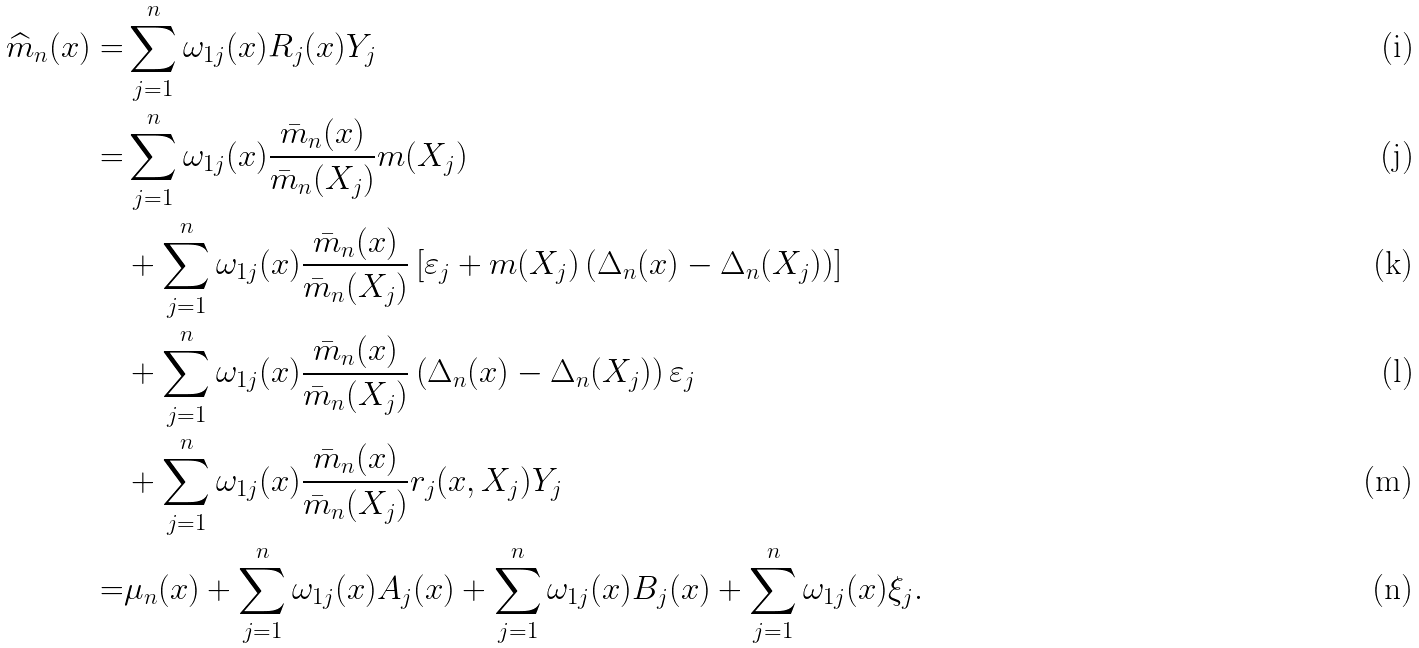Convert formula to latex. <formula><loc_0><loc_0><loc_500><loc_500>\widehat { m } _ { n } ( x ) = & \sum _ { j = 1 } ^ { n } \omega _ { 1 j } ( x ) R _ { j } ( x ) Y _ { j } \\ = & \sum _ { j = 1 } ^ { n } \omega _ { 1 j } ( x ) \frac { \bar { m } _ { n } ( x ) } { \bar { m } _ { n } ( X _ { j } ) } m ( X _ { j } ) \\ \quad & + \sum _ { j = 1 } ^ { n } \omega _ { 1 j } ( x ) \frac { \bar { m } _ { n } ( x ) } { \bar { m } _ { n } ( X _ { j } ) } \left [ \varepsilon _ { j } + m ( X _ { j } ) \left ( \Delta _ { n } ( x ) - \Delta _ { n } ( X _ { j } ) \right ) \right ] \\ \quad & + \sum _ { j = 1 } ^ { n } \omega _ { 1 j } ( x ) \frac { \bar { m } _ { n } ( x ) } { \bar { m } _ { n } ( X _ { j } ) } \left ( \Delta _ { n } ( x ) - \Delta _ { n } ( X _ { j } ) \right ) \varepsilon _ { j } \\ \quad & + \sum _ { j = 1 } ^ { n } \omega _ { 1 j } ( x ) \frac { \bar { m } _ { n } ( x ) } { \bar { m } _ { n } ( X _ { j } ) } r _ { j } ( x , X _ { j } ) Y _ { j } \\ = & \mu _ { n } ( x ) + \sum _ { j = 1 } ^ { n } \omega _ { 1 j } ( x ) A _ { j } ( x ) + \sum _ { j = 1 } ^ { n } \omega _ { 1 j } ( x ) B _ { j } ( x ) + \sum _ { j = 1 } ^ { n } \omega _ { 1 j } ( x ) \xi _ { j } .</formula> 